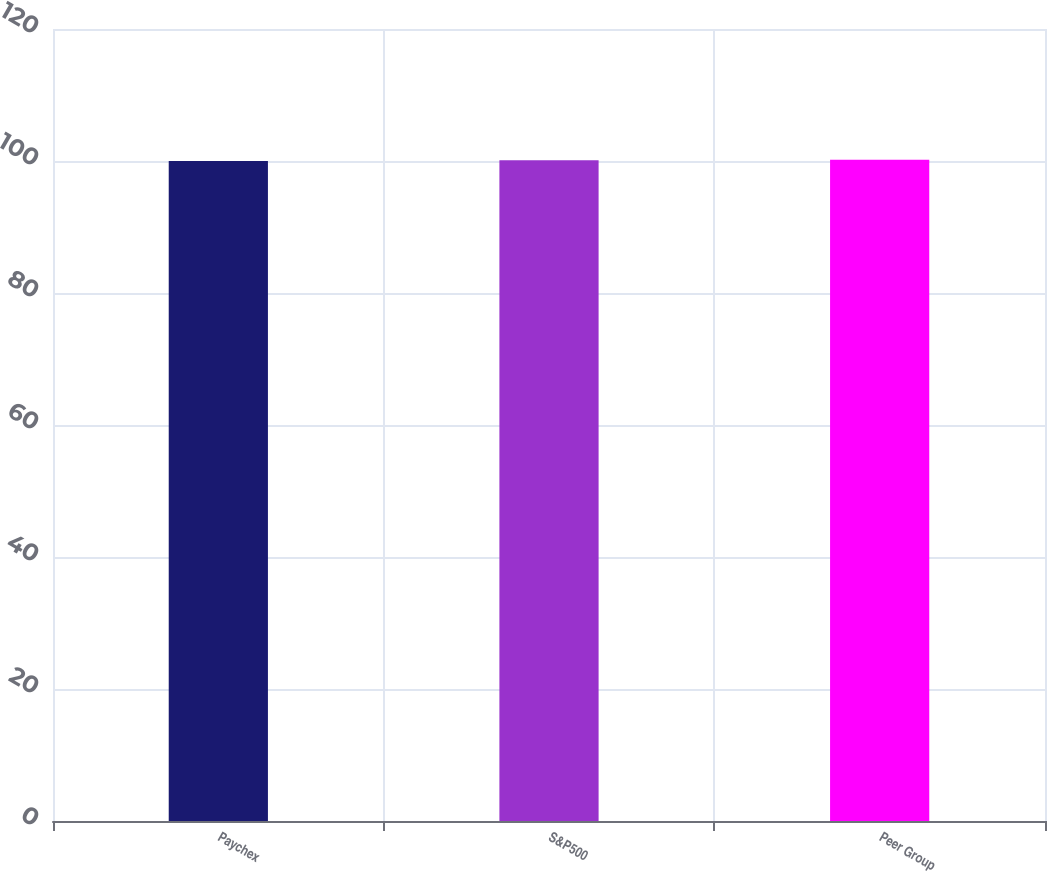<chart> <loc_0><loc_0><loc_500><loc_500><bar_chart><fcel>Paychex<fcel>S&P500<fcel>Peer Group<nl><fcel>100<fcel>100.1<fcel>100.2<nl></chart> 